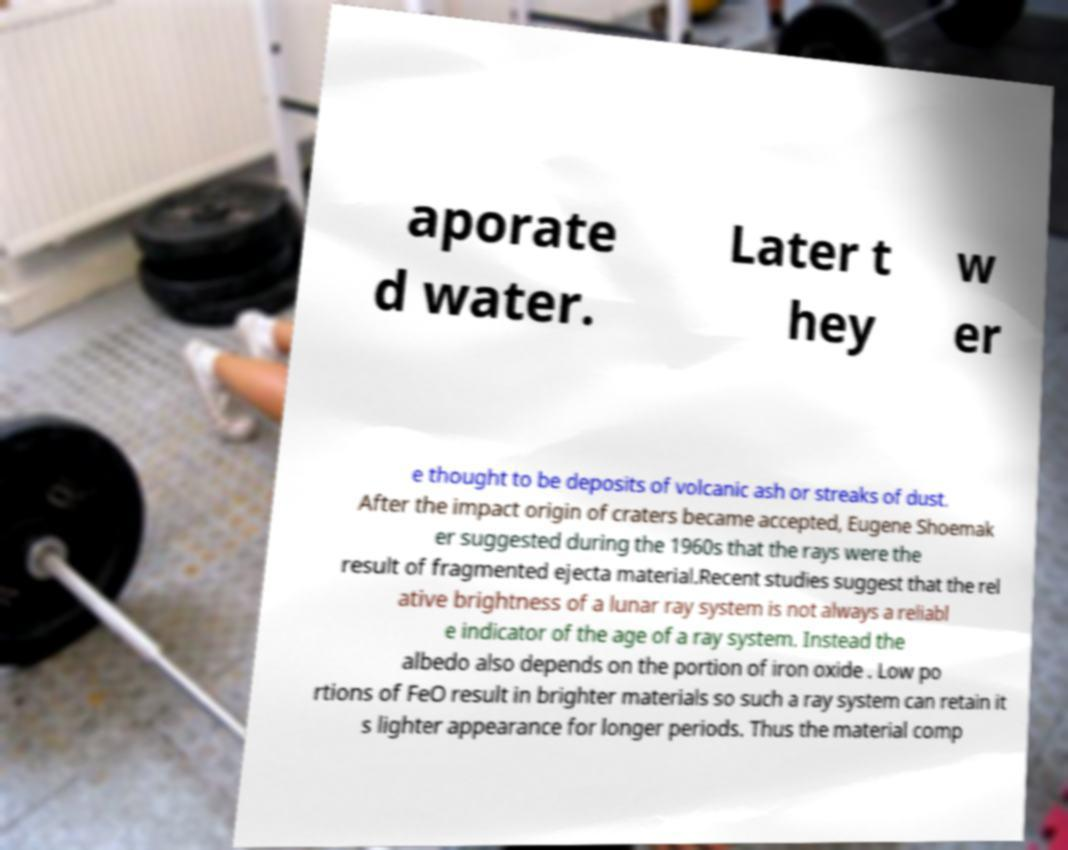I need the written content from this picture converted into text. Can you do that? aporate d water. Later t hey w er e thought to be deposits of volcanic ash or streaks of dust. After the impact origin of craters became accepted, Eugene Shoemak er suggested during the 1960s that the rays were the result of fragmented ejecta material.Recent studies suggest that the rel ative brightness of a lunar ray system is not always a reliabl e indicator of the age of a ray system. Instead the albedo also depends on the portion of iron oxide . Low po rtions of FeO result in brighter materials so such a ray system can retain it s lighter appearance for longer periods. Thus the material comp 